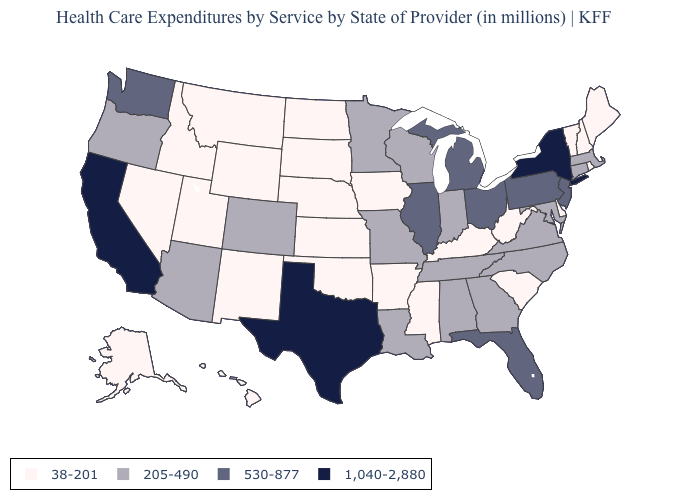What is the lowest value in the USA?
Be succinct. 38-201. What is the value of Virginia?
Answer briefly. 205-490. What is the value of New York?
Keep it brief. 1,040-2,880. Name the states that have a value in the range 1,040-2,880?
Keep it brief. California, New York, Texas. Among the states that border Kansas , does Oklahoma have the lowest value?
Quick response, please. Yes. Among the states that border Pennsylvania , which have the highest value?
Answer briefly. New York. What is the highest value in the Northeast ?
Concise answer only. 1,040-2,880. Among the states that border Utah , which have the highest value?
Concise answer only. Arizona, Colorado. What is the value of Maryland?
Concise answer only. 205-490. Does Colorado have the lowest value in the USA?
Quick response, please. No. What is the value of Ohio?
Write a very short answer. 530-877. What is the value of North Dakota?
Quick response, please. 38-201. What is the lowest value in the USA?
Short answer required. 38-201. Among the states that border Missouri , does Iowa have the lowest value?
Keep it brief. Yes. 